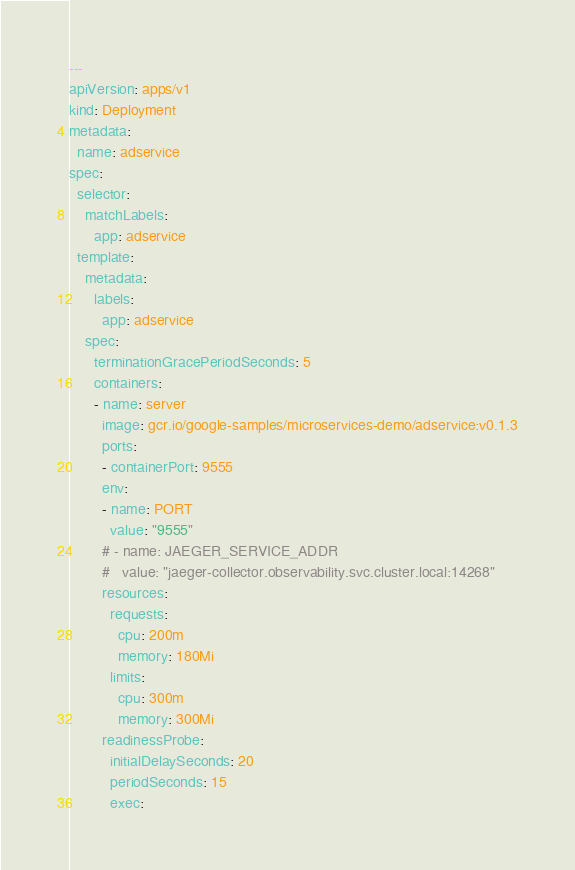<code> <loc_0><loc_0><loc_500><loc_500><_YAML_>---
apiVersion: apps/v1
kind: Deployment
metadata:
  name: adservice
spec:
  selector:
    matchLabels:
      app: adservice
  template:
    metadata:
      labels:
        app: adservice
    spec:
      terminationGracePeriodSeconds: 5
      containers:
      - name: server
        image: gcr.io/google-samples/microservices-demo/adservice:v0.1.3
        ports:
        - containerPort: 9555
        env:
        - name: PORT
          value: "9555"
        # - name: JAEGER_SERVICE_ADDR
        #   value: "jaeger-collector.observability.svc.cluster.local:14268"
        resources:
          requests:
            cpu: 200m
            memory: 180Mi
          limits:
            cpu: 300m
            memory: 300Mi
        readinessProbe:
          initialDelaySeconds: 20
          periodSeconds: 15
          exec:</code> 